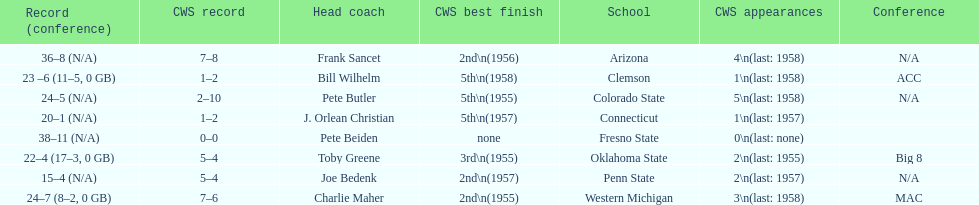Does clemson or western michigan have more cws appearances? Western Michigan. 